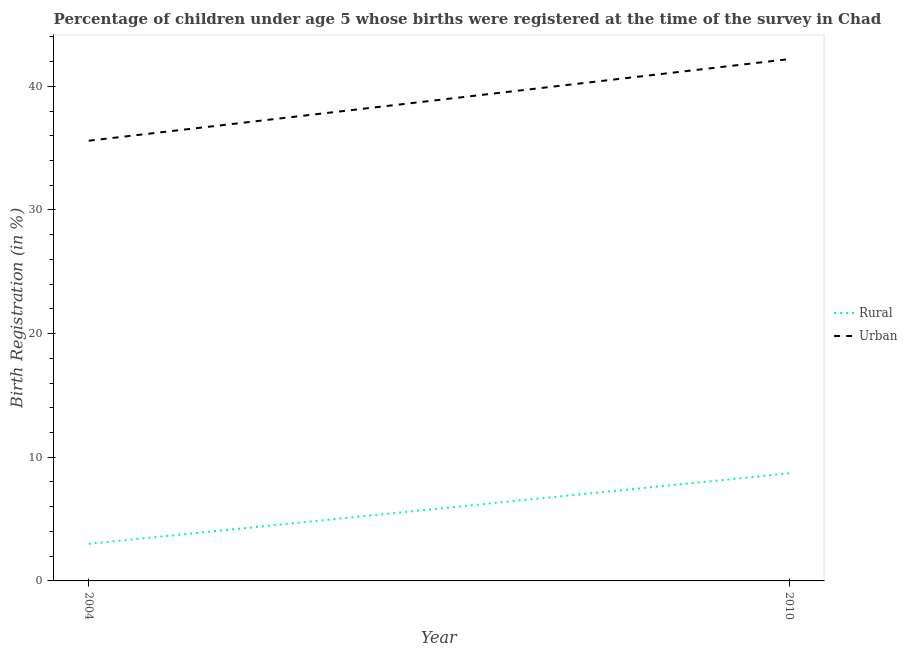How many different coloured lines are there?
Offer a very short reply. 2. Is the number of lines equal to the number of legend labels?
Keep it short and to the point. Yes. Across all years, what is the maximum urban birth registration?
Make the answer very short. 42.2. Across all years, what is the minimum urban birth registration?
Give a very brief answer. 35.6. In which year was the urban birth registration maximum?
Offer a very short reply. 2010. In which year was the urban birth registration minimum?
Give a very brief answer. 2004. What is the difference between the rural birth registration in 2004 and that in 2010?
Provide a short and direct response. -5.7. What is the difference between the rural birth registration in 2004 and the urban birth registration in 2010?
Provide a succinct answer. -39.2. What is the average urban birth registration per year?
Provide a short and direct response. 38.9. In the year 2010, what is the difference between the urban birth registration and rural birth registration?
Your answer should be very brief. 33.5. What is the ratio of the urban birth registration in 2004 to that in 2010?
Your response must be concise. 0.84. Does the rural birth registration monotonically increase over the years?
Provide a succinct answer. Yes. Is the rural birth registration strictly less than the urban birth registration over the years?
Give a very brief answer. Yes. How many lines are there?
Your answer should be compact. 2. What is the difference between two consecutive major ticks on the Y-axis?
Your answer should be compact. 10. Does the graph contain any zero values?
Offer a terse response. No. What is the title of the graph?
Give a very brief answer. Percentage of children under age 5 whose births were registered at the time of the survey in Chad. Does "Working only" appear as one of the legend labels in the graph?
Keep it short and to the point. No. What is the label or title of the X-axis?
Your answer should be compact. Year. What is the label or title of the Y-axis?
Give a very brief answer. Birth Registration (in %). What is the Birth Registration (in %) of Urban in 2004?
Offer a terse response. 35.6. What is the Birth Registration (in %) in Urban in 2010?
Your response must be concise. 42.2. Across all years, what is the maximum Birth Registration (in %) in Urban?
Keep it short and to the point. 42.2. Across all years, what is the minimum Birth Registration (in %) in Rural?
Your answer should be compact. 3. Across all years, what is the minimum Birth Registration (in %) of Urban?
Provide a succinct answer. 35.6. What is the total Birth Registration (in %) in Rural in the graph?
Provide a succinct answer. 11.7. What is the total Birth Registration (in %) in Urban in the graph?
Make the answer very short. 77.8. What is the difference between the Birth Registration (in %) in Urban in 2004 and that in 2010?
Provide a succinct answer. -6.6. What is the difference between the Birth Registration (in %) of Rural in 2004 and the Birth Registration (in %) of Urban in 2010?
Offer a terse response. -39.2. What is the average Birth Registration (in %) in Rural per year?
Ensure brevity in your answer.  5.85. What is the average Birth Registration (in %) of Urban per year?
Give a very brief answer. 38.9. In the year 2004, what is the difference between the Birth Registration (in %) of Rural and Birth Registration (in %) of Urban?
Offer a very short reply. -32.6. In the year 2010, what is the difference between the Birth Registration (in %) of Rural and Birth Registration (in %) of Urban?
Offer a very short reply. -33.5. What is the ratio of the Birth Registration (in %) of Rural in 2004 to that in 2010?
Offer a very short reply. 0.34. What is the ratio of the Birth Registration (in %) in Urban in 2004 to that in 2010?
Give a very brief answer. 0.84. What is the difference between the highest and the second highest Birth Registration (in %) in Rural?
Make the answer very short. 5.7. What is the difference between the highest and the lowest Birth Registration (in %) in Rural?
Provide a short and direct response. 5.7. 